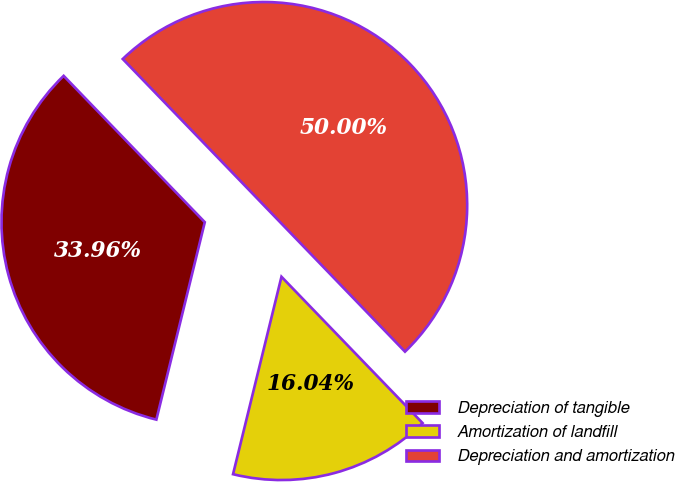Convert chart to OTSL. <chart><loc_0><loc_0><loc_500><loc_500><pie_chart><fcel>Depreciation of tangible<fcel>Amortization of landfill<fcel>Depreciation and amortization<nl><fcel>33.96%<fcel>16.04%<fcel>50.0%<nl></chart> 